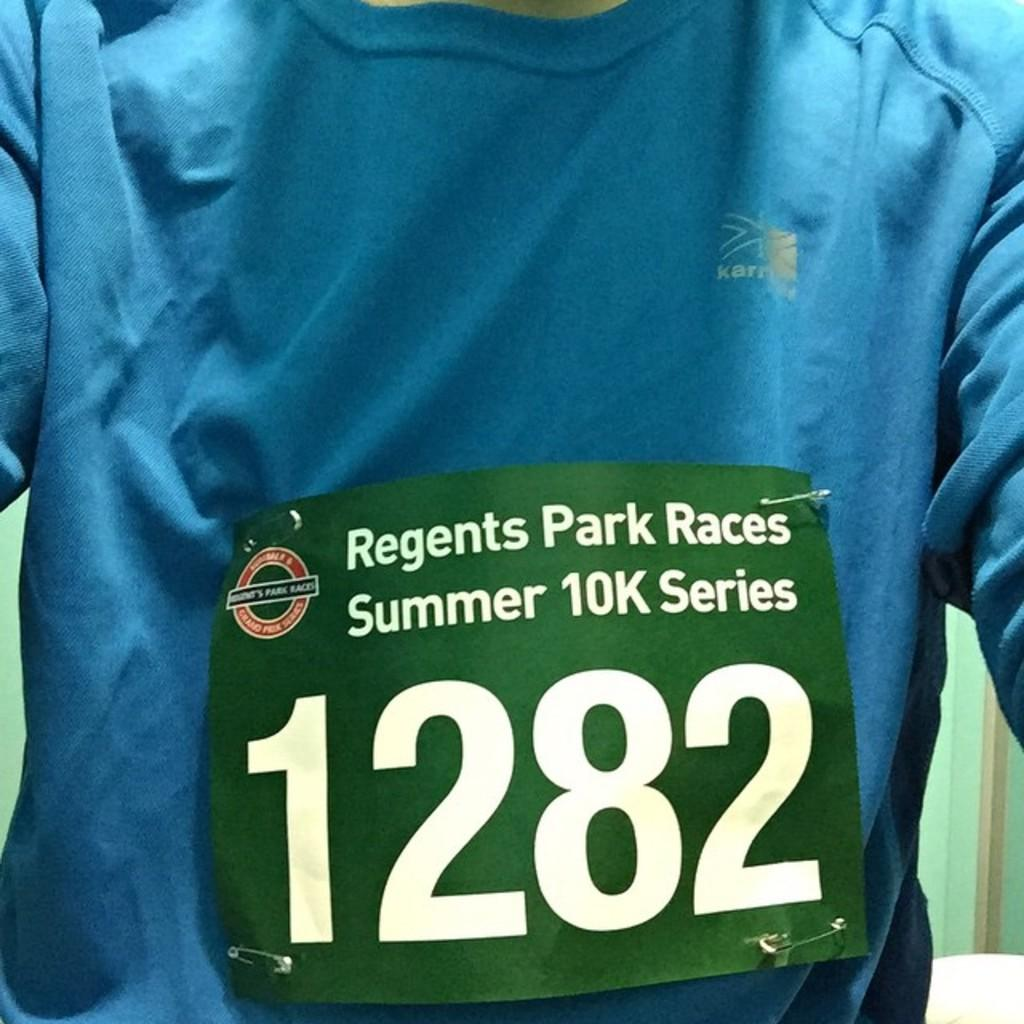<image>
Render a clear and concise summary of the photo. A sign in front of a shirt that says, "Regents Park Races Summer 10k Series 1282." 